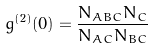<formula> <loc_0><loc_0><loc_500><loc_500>g ^ { ( 2 ) } ( 0 ) = \frac { N _ { A B C } N _ { C } } { N _ { A C } N _ { B C } }</formula> 